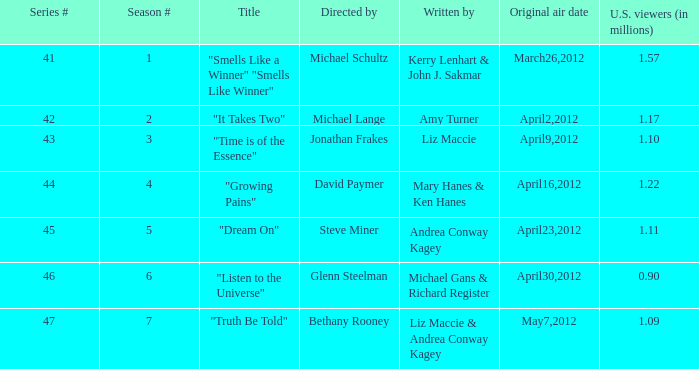What is the name of the episode/s authored by michael gans & richard register? "Listen to the Universe". 